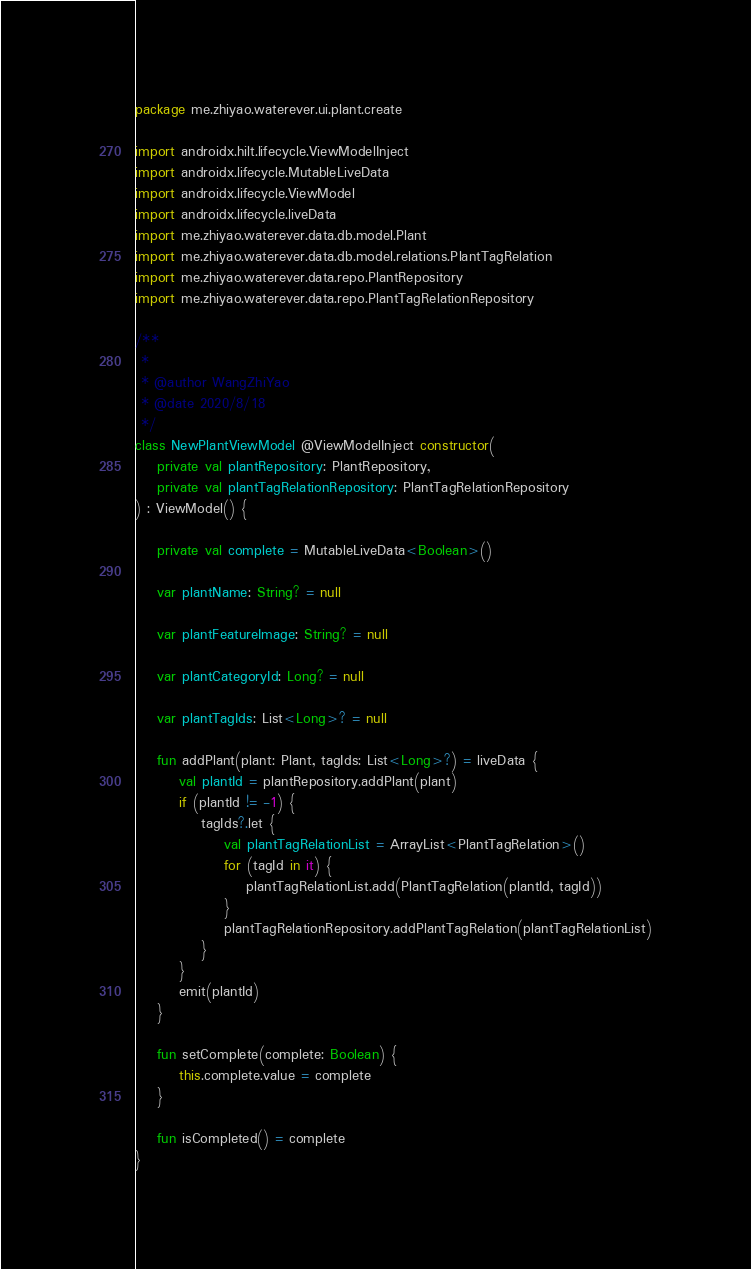Convert code to text. <code><loc_0><loc_0><loc_500><loc_500><_Kotlin_>package me.zhiyao.waterever.ui.plant.create

import androidx.hilt.lifecycle.ViewModelInject
import androidx.lifecycle.MutableLiveData
import androidx.lifecycle.ViewModel
import androidx.lifecycle.liveData
import me.zhiyao.waterever.data.db.model.Plant
import me.zhiyao.waterever.data.db.model.relations.PlantTagRelation
import me.zhiyao.waterever.data.repo.PlantRepository
import me.zhiyao.waterever.data.repo.PlantTagRelationRepository

/**
 *
 * @author WangZhiYao
 * @date 2020/8/18
 */
class NewPlantViewModel @ViewModelInject constructor(
    private val plantRepository: PlantRepository,
    private val plantTagRelationRepository: PlantTagRelationRepository
) : ViewModel() {

    private val complete = MutableLiveData<Boolean>()

    var plantName: String? = null

    var plantFeatureImage: String? = null

    var plantCategoryId: Long? = null

    var plantTagIds: List<Long>? = null

    fun addPlant(plant: Plant, tagIds: List<Long>?) = liveData {
        val plantId = plantRepository.addPlant(plant)
        if (plantId != -1) {
            tagIds?.let {
                val plantTagRelationList = ArrayList<PlantTagRelation>()
                for (tagId in it) {
                    plantTagRelationList.add(PlantTagRelation(plantId, tagId))
                }
                plantTagRelationRepository.addPlantTagRelation(plantTagRelationList)
            }
        }
        emit(plantId)
    }

    fun setComplete(complete: Boolean) {
        this.complete.value = complete
    }

    fun isCompleted() = complete
}</code> 